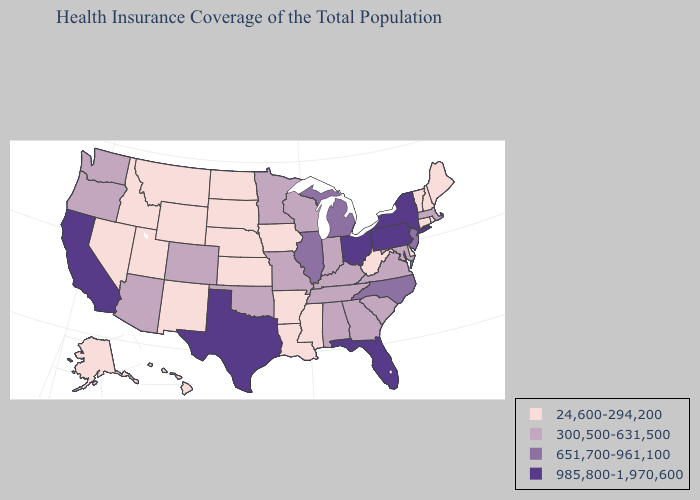Does Nevada have the highest value in the West?
Write a very short answer. No. Does Tennessee have a lower value than Massachusetts?
Write a very short answer. No. Is the legend a continuous bar?
Keep it brief. No. Which states have the lowest value in the West?
Quick response, please. Alaska, Hawaii, Idaho, Montana, Nevada, New Mexico, Utah, Wyoming. What is the value of Delaware?
Concise answer only. 24,600-294,200. Does Idaho have the lowest value in the West?
Keep it brief. Yes. What is the highest value in the USA?
Short answer required. 985,800-1,970,600. Among the states that border Idaho , does Oregon have the highest value?
Concise answer only. Yes. Does Washington have the lowest value in the USA?
Quick response, please. No. Name the states that have a value in the range 651,700-961,100?
Give a very brief answer. Illinois, Michigan, New Jersey, North Carolina. Does Alaska have the lowest value in the USA?
Be succinct. Yes. Name the states that have a value in the range 985,800-1,970,600?
Be succinct. California, Florida, New York, Ohio, Pennsylvania, Texas. Does Kentucky have the lowest value in the USA?
Quick response, please. No. What is the lowest value in the West?
Write a very short answer. 24,600-294,200. 